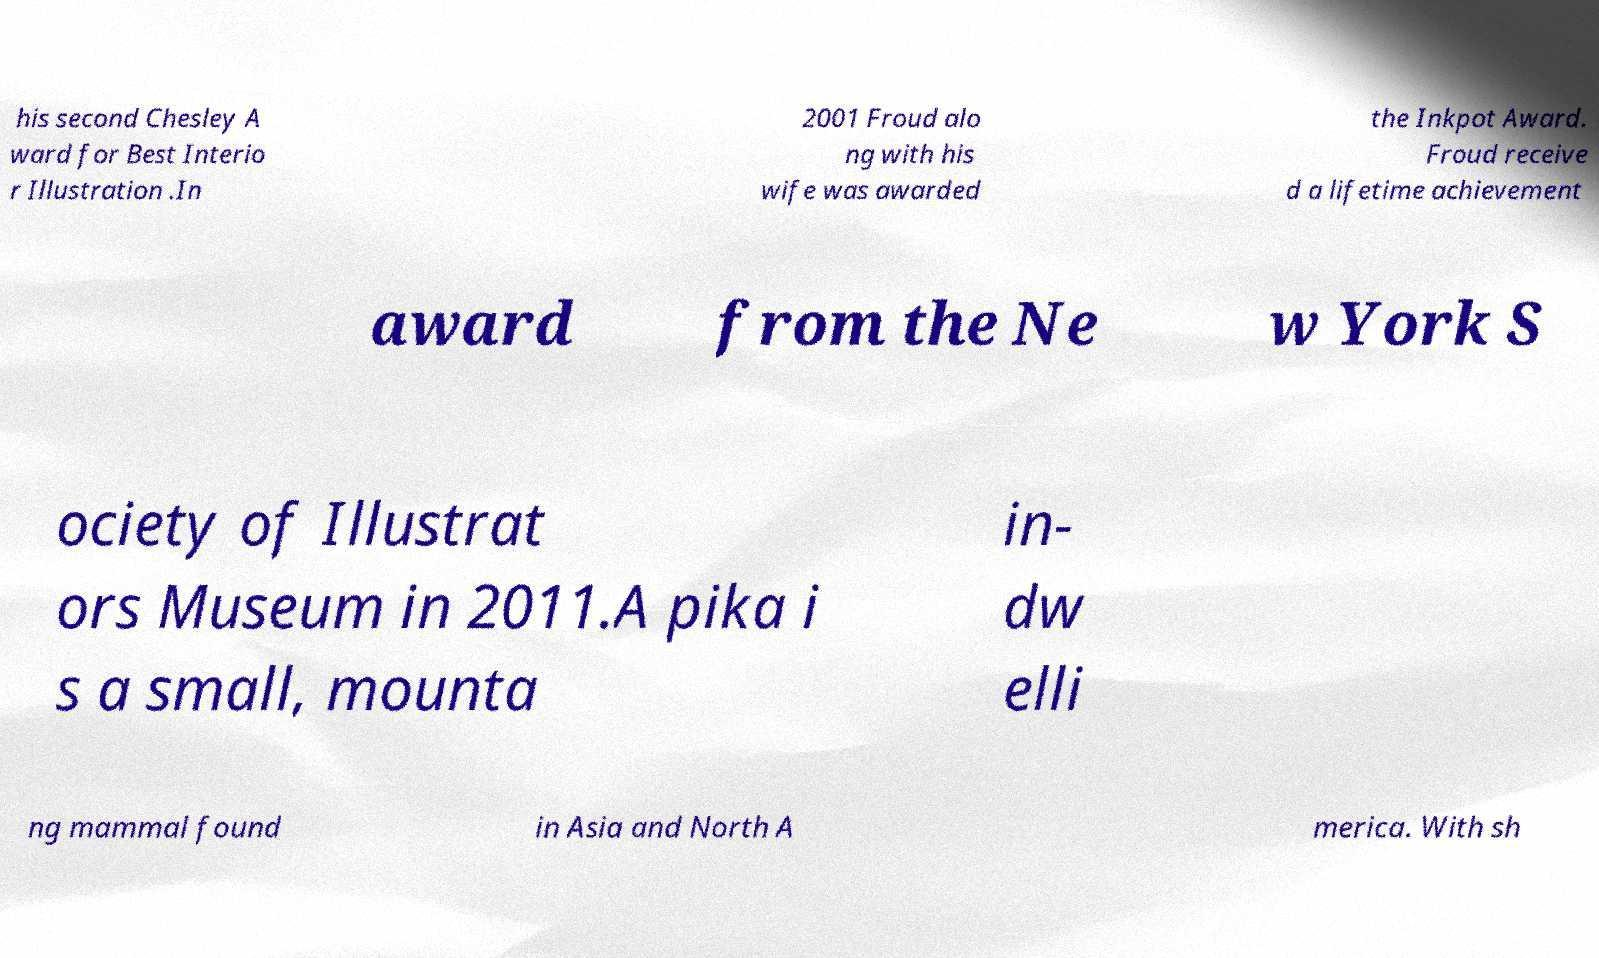Can you read and provide the text displayed in the image?This photo seems to have some interesting text. Can you extract and type it out for me? his second Chesley A ward for Best Interio r Illustration .In 2001 Froud alo ng with his wife was awarded the Inkpot Award. Froud receive d a lifetime achievement award from the Ne w York S ociety of Illustrat ors Museum in 2011.A pika i s a small, mounta in- dw elli ng mammal found in Asia and North A merica. With sh 